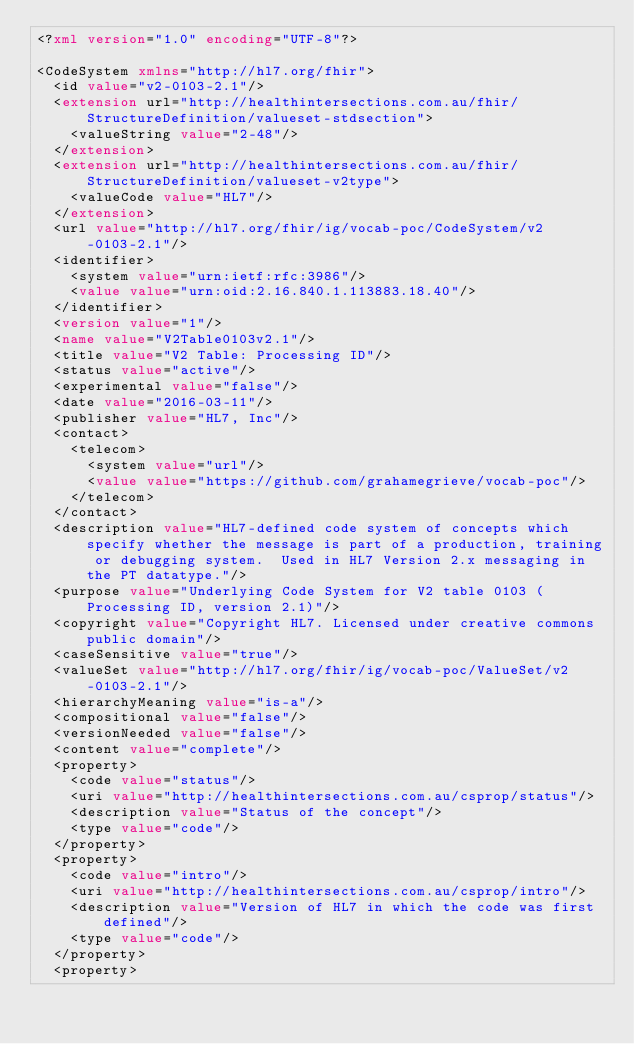<code> <loc_0><loc_0><loc_500><loc_500><_XML_><?xml version="1.0" encoding="UTF-8"?>

<CodeSystem xmlns="http://hl7.org/fhir">
  <id value="v2-0103-2.1"/>
  <extension url="http://healthintersections.com.au/fhir/StructureDefinition/valueset-stdsection">
    <valueString value="2-48"/>
  </extension>
  <extension url="http://healthintersections.com.au/fhir/StructureDefinition/valueset-v2type">
    <valueCode value="HL7"/>
  </extension>
  <url value="http://hl7.org/fhir/ig/vocab-poc/CodeSystem/v2-0103-2.1"/>
  <identifier>
    <system value="urn:ietf:rfc:3986"/>
    <value value="urn:oid:2.16.840.1.113883.18.40"/>
  </identifier>
  <version value="1"/>
  <name value="V2Table0103v2.1"/>
  <title value="V2 Table: Processing ID"/>
  <status value="active"/>
  <experimental value="false"/>
  <date value="2016-03-11"/>
  <publisher value="HL7, Inc"/>
  <contact>
    <telecom>
      <system value="url"/>
      <value value="https://github.com/grahamegrieve/vocab-poc"/>
    </telecom>
  </contact>
  <description value="HL7-defined code system of concepts which specify whether the message is part of a production, training or debugging system.  Used in HL7 Version 2.x messaging in the PT datatype."/>
  <purpose value="Underlying Code System for V2 table 0103 (Processing ID, version 2.1)"/>
  <copyright value="Copyright HL7. Licensed under creative commons public domain"/>
  <caseSensitive value="true"/>
  <valueSet value="http://hl7.org/fhir/ig/vocab-poc/ValueSet/v2-0103-2.1"/>
  <hierarchyMeaning value="is-a"/>
  <compositional value="false"/>
  <versionNeeded value="false"/>
  <content value="complete"/>
  <property>
    <code value="status"/>
    <uri value="http://healthintersections.com.au/csprop/status"/>
    <description value="Status of the concept"/>
    <type value="code"/>
  </property>
  <property>
    <code value="intro"/>
    <uri value="http://healthintersections.com.au/csprop/intro"/>
    <description value="Version of HL7 in which the code was first defined"/>
    <type value="code"/>
  </property>
  <property></code> 